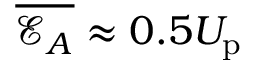<formula> <loc_0><loc_0><loc_500><loc_500>\overline { { \mathcal { E } _ { A } } } \approx 0 . 5 U _ { p }</formula> 